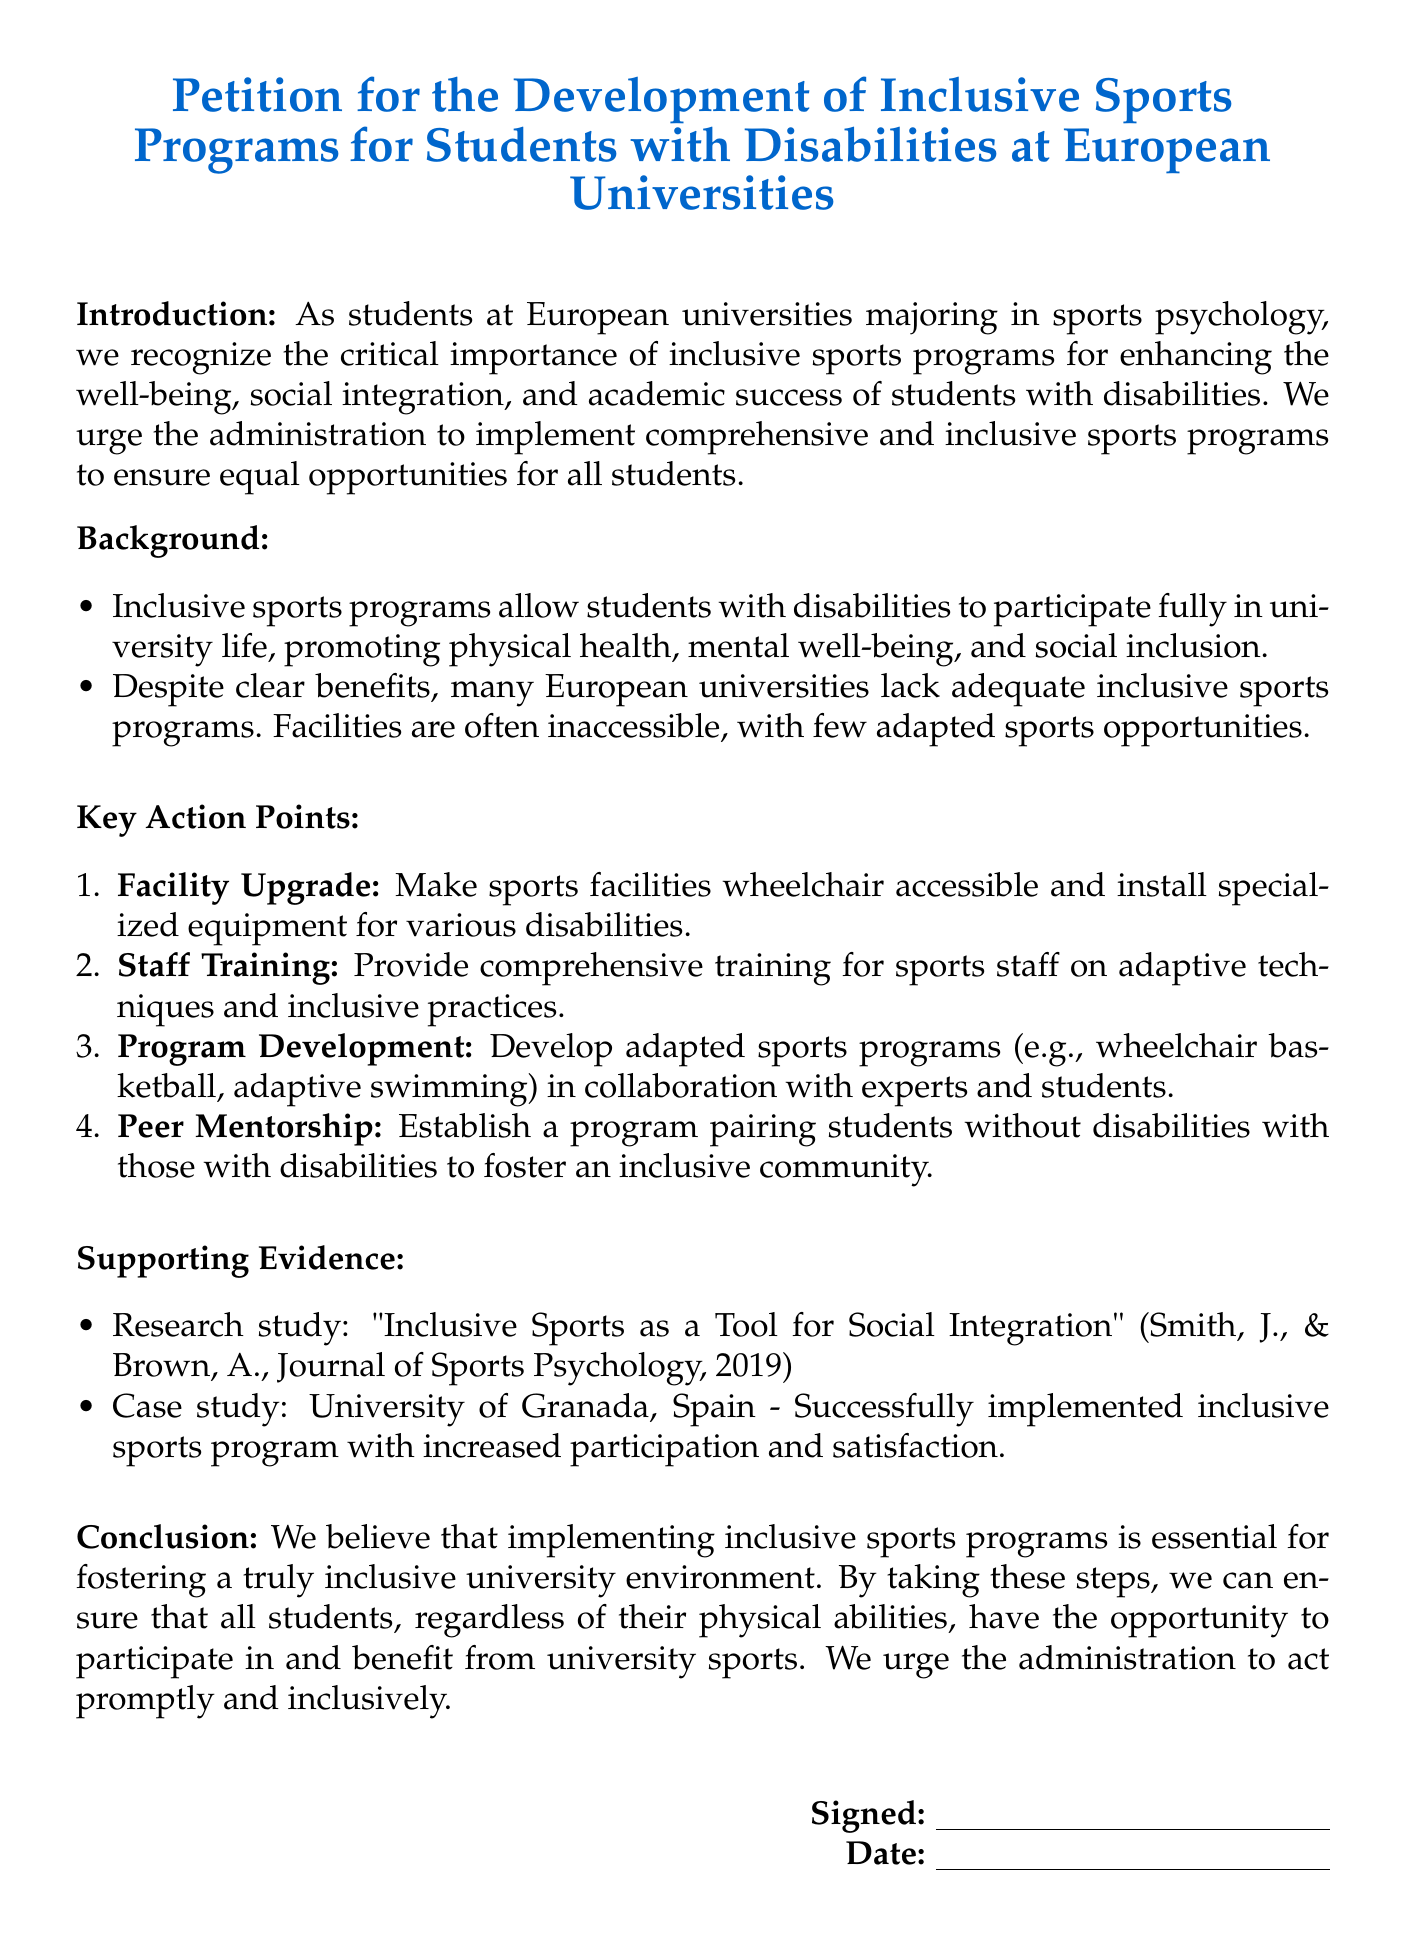What is the title of the petition? The title of the petition is clearly stated at the beginning of the document.
Answer: Petition for the Development of Inclusive Sports Programs for Students with Disabilities at European Universities What is one key action point mentioned in the petition? The document lists several action points for the development of inclusive sports programs.
Answer: Facility Upgrade Who conducted the research study cited in the supporting evidence? The supporting evidence section references a research study and its authors.
Answer: Smith, J., & Brown, A What is the case study example provided in the document? The case study included in the evidence section serves as an illustration of a successful program.
Answer: University of Granada, Spain How many key action points are listed in the document? The number of key action points is specifically enumerated in the document.
Answer: Four What is the primary benefit of inclusive sports programs mentioned? The introduction emphasizes the importance of inclusive sports programs for a specific outcome.
Answer: Social integration What date is mentioned in the signature section? The document includes a section for the date of signing but does not specify a particular date.
Answer: N/A What type of programs are specifically mentioned for development? The petition proposes the creation of specific types of sports programs for adaptation.
Answer: Adapted sports programs What is the intended audience for this petition? The introductory text indicates the intended demographic for the petition's advocacy.
Answer: Administration 